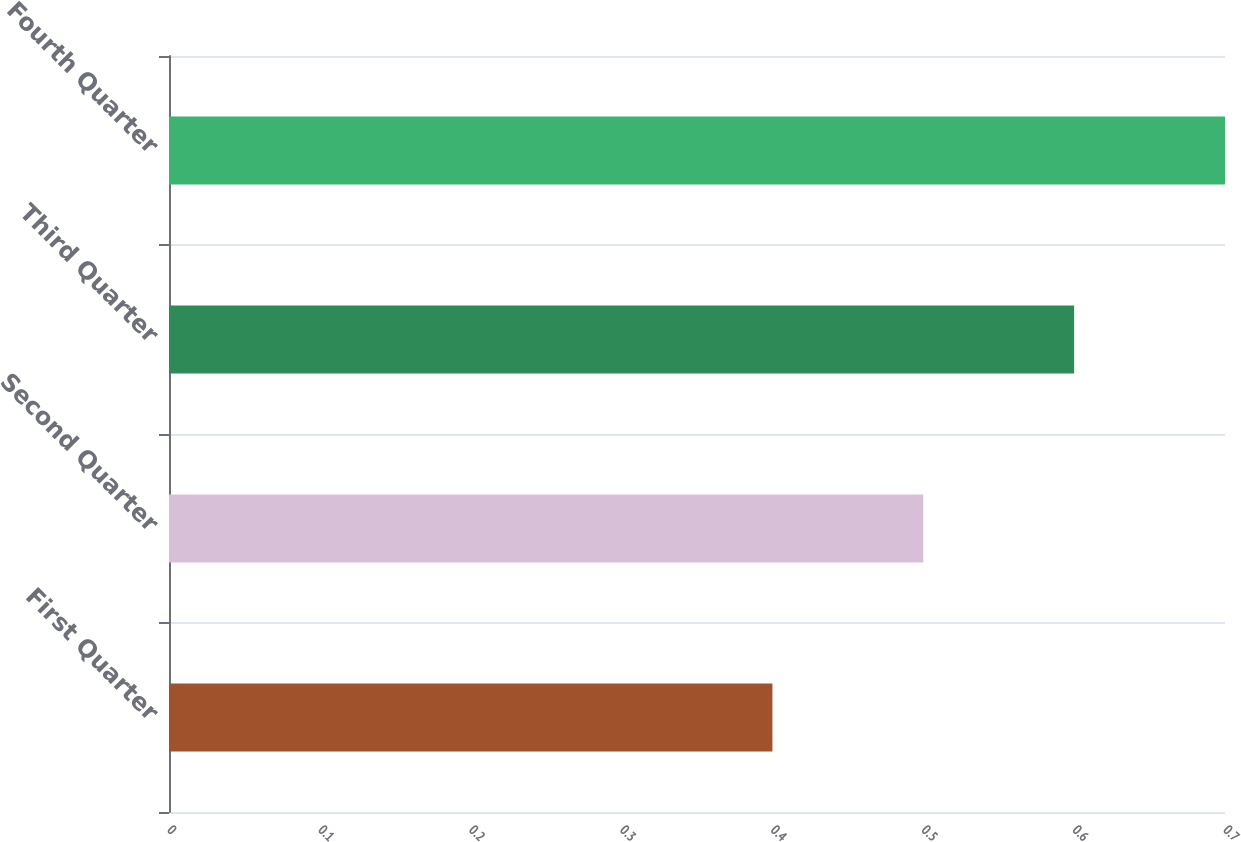<chart> <loc_0><loc_0><loc_500><loc_500><bar_chart><fcel>First Quarter<fcel>Second Quarter<fcel>Third Quarter<fcel>Fourth Quarter<nl><fcel>0.4<fcel>0.5<fcel>0.6<fcel>0.7<nl></chart> 